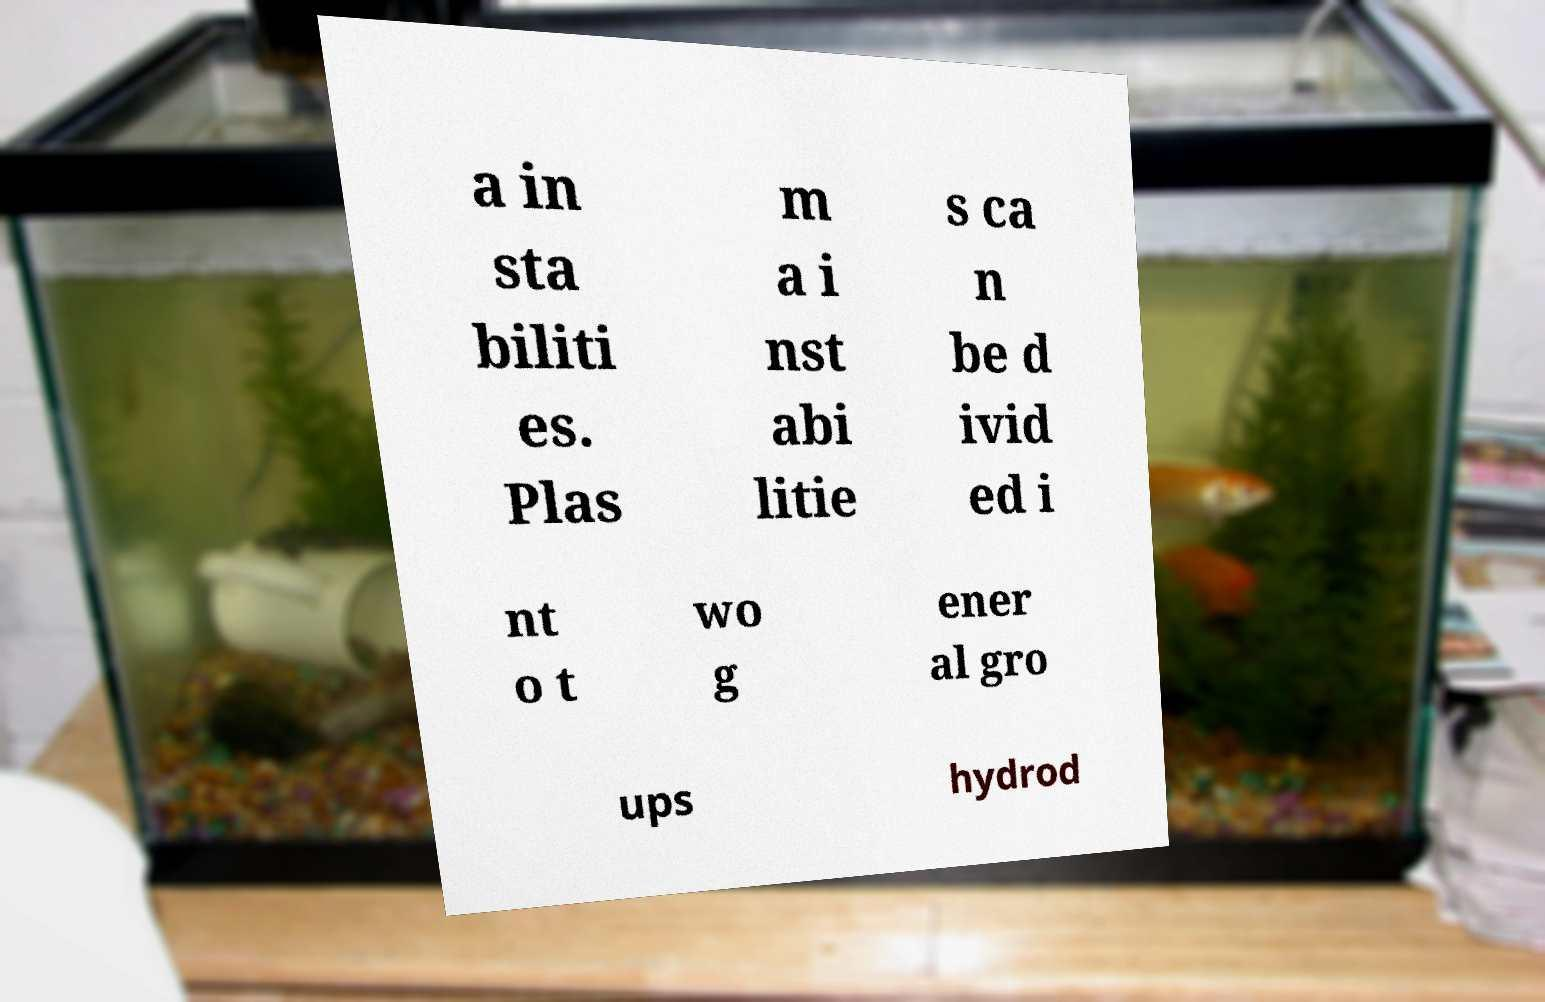There's text embedded in this image that I need extracted. Can you transcribe it verbatim? a in sta biliti es. Plas m a i nst abi litie s ca n be d ivid ed i nt o t wo g ener al gro ups hydrod 